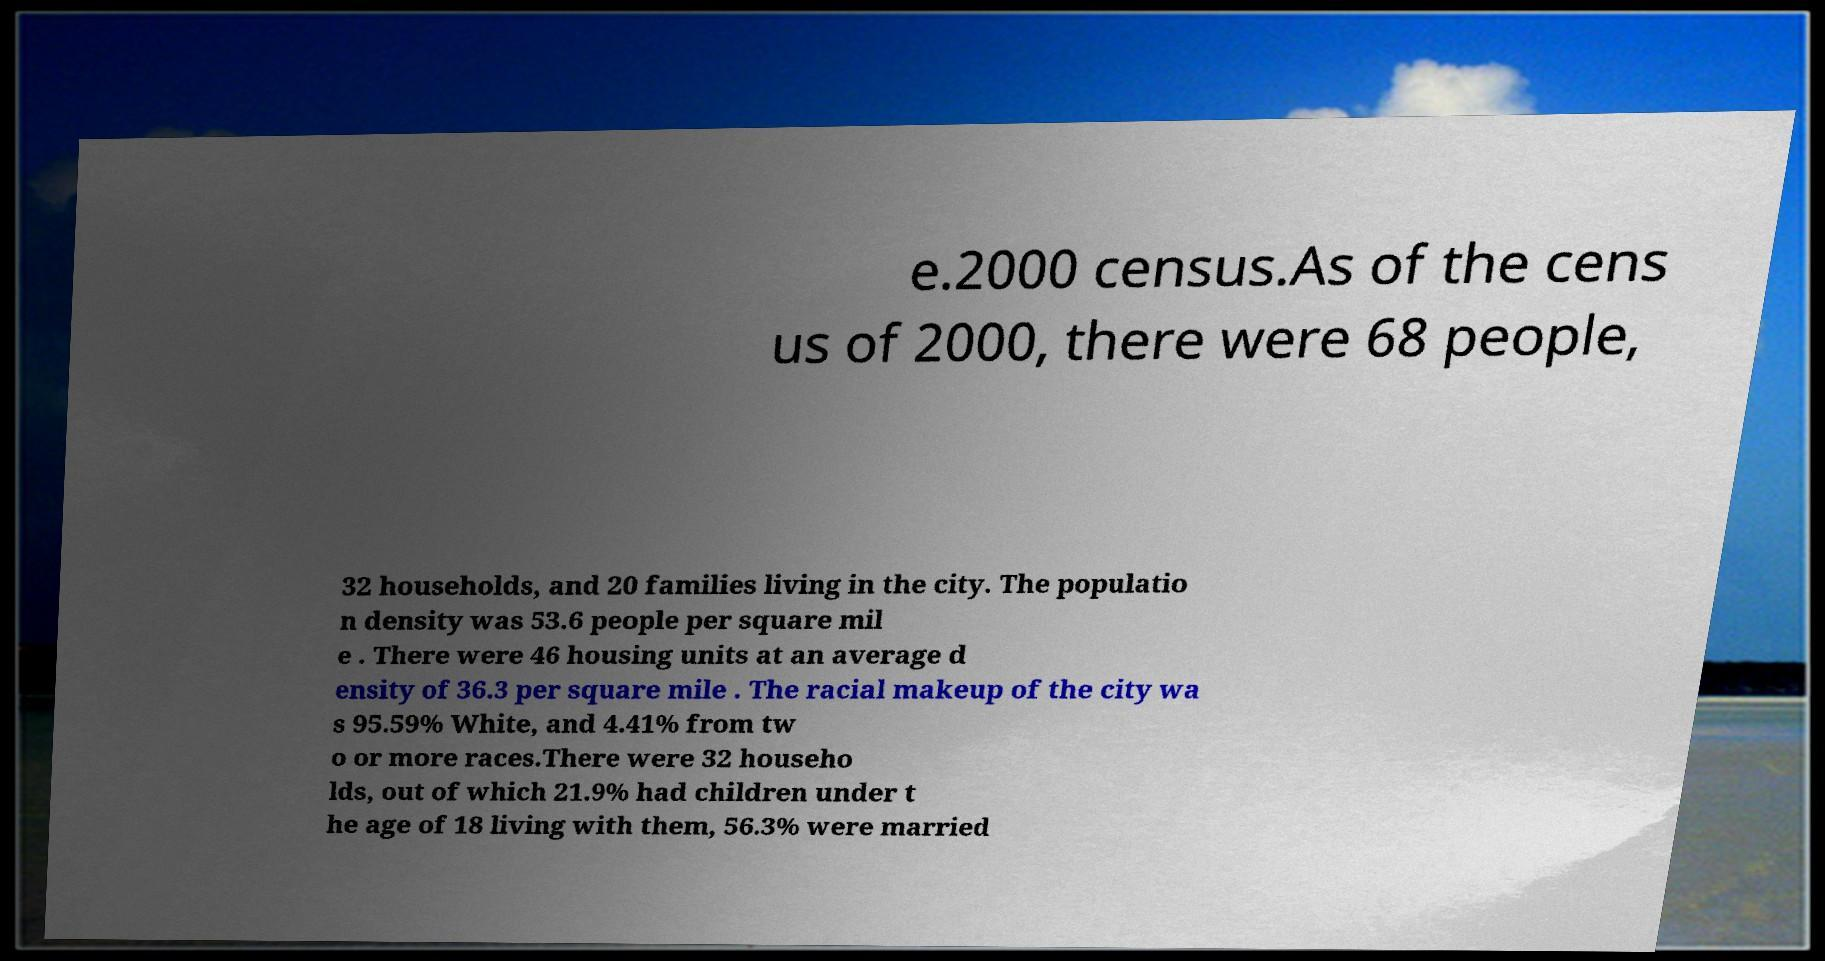Please identify and transcribe the text found in this image. e.2000 census.As of the cens us of 2000, there were 68 people, 32 households, and 20 families living in the city. The populatio n density was 53.6 people per square mil e . There were 46 housing units at an average d ensity of 36.3 per square mile . The racial makeup of the city wa s 95.59% White, and 4.41% from tw o or more races.There were 32 househo lds, out of which 21.9% had children under t he age of 18 living with them, 56.3% were married 